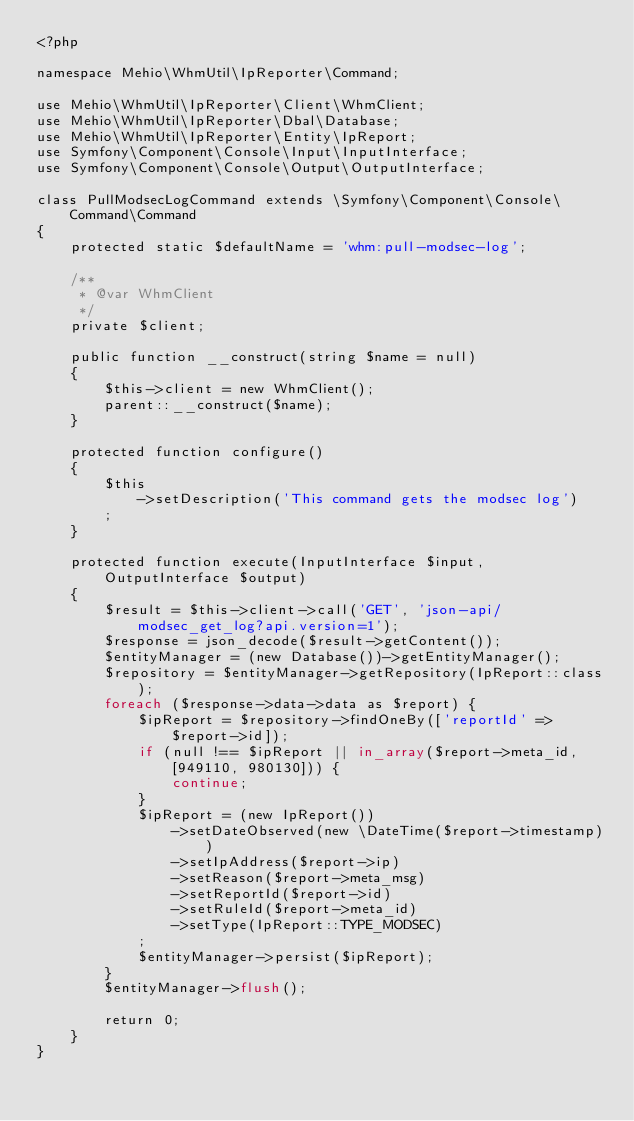<code> <loc_0><loc_0><loc_500><loc_500><_PHP_><?php

namespace Mehio\WhmUtil\IpReporter\Command;

use Mehio\WhmUtil\IpReporter\Client\WhmClient;
use Mehio\WhmUtil\IpReporter\Dbal\Database;
use Mehio\WhmUtil\IpReporter\Entity\IpReport;
use Symfony\Component\Console\Input\InputInterface;
use Symfony\Component\Console\Output\OutputInterface;

class PullModsecLogCommand extends \Symfony\Component\Console\Command\Command
{
    protected static $defaultName = 'whm:pull-modsec-log';

    /**
     * @var WhmClient
     */
    private $client;

    public function __construct(string $name = null)
    {
        $this->client = new WhmClient();
        parent::__construct($name);
    }

    protected function configure()
    {
        $this
            ->setDescription('This command gets the modsec log')
        ;
    }

    protected function execute(InputInterface $input, OutputInterface $output)
    {
        $result = $this->client->call('GET', 'json-api/modsec_get_log?api.version=1');
        $response = json_decode($result->getContent());
        $entityManager = (new Database())->getEntityManager();
        $repository = $entityManager->getRepository(IpReport::class);
        foreach ($response->data->data as $report) {
            $ipReport = $repository->findOneBy(['reportId' => $report->id]);
            if (null !== $ipReport || in_array($report->meta_id, [949110, 980130])) {
                continue;
            }
            $ipReport = (new IpReport())
                ->setDateObserved(new \DateTime($report->timestamp))
                ->setIpAddress($report->ip)
                ->setReason($report->meta_msg)
                ->setReportId($report->id)
                ->setRuleId($report->meta_id)
                ->setType(IpReport::TYPE_MODSEC)
            ;
            $entityManager->persist($ipReport);
        }
        $entityManager->flush();

        return 0;
    }
}
</code> 